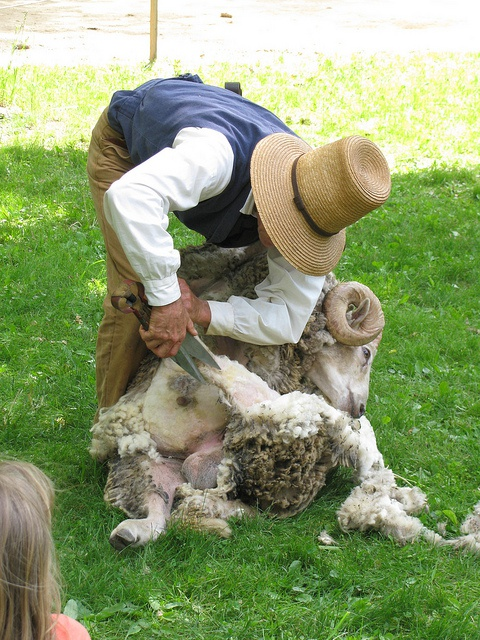Describe the objects in this image and their specific colors. I can see people in lightgray, white, olive, black, and tan tones, sheep in lightgray, gray, darkgray, and black tones, people in lightgray, darkgray, and gray tones, and scissors in lightgray, gray, olive, black, and maroon tones in this image. 